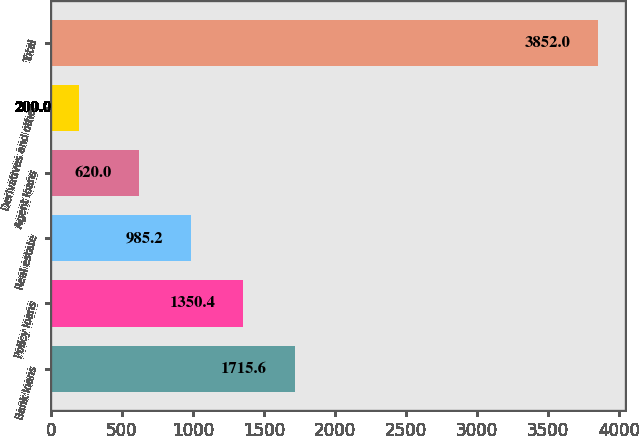<chart> <loc_0><loc_0><loc_500><loc_500><bar_chart><fcel>Bank loans<fcel>Policy loans<fcel>Real estate<fcel>Agent loans<fcel>Derivatives and other<fcel>Total<nl><fcel>1715.6<fcel>1350.4<fcel>985.2<fcel>620<fcel>200<fcel>3852<nl></chart> 